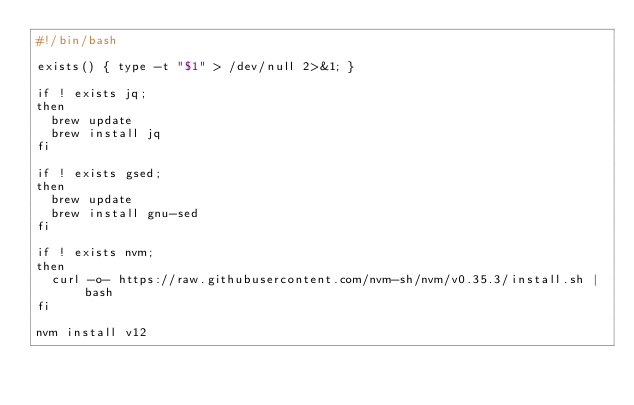Convert code to text. <code><loc_0><loc_0><loc_500><loc_500><_Bash_>#!/bin/bash

exists() { type -t "$1" > /dev/null 2>&1; }

if ! exists jq;
then
	brew update
	brew install jq
fi

if ! exists gsed;
then
	brew update
	brew install gnu-sed
fi

if ! exists nvm;
then
	curl -o- https://raw.githubusercontent.com/nvm-sh/nvm/v0.35.3/install.sh | bash
fi

nvm install v12</code> 